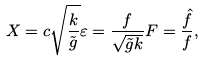Convert formula to latex. <formula><loc_0><loc_0><loc_500><loc_500>X = c \sqrt { \frac { k } { \tilde { g } } } \varepsilon = \frac { f } { \sqrt { \tilde { g } k } } F = \frac { \hat { f } } { f } ,</formula> 